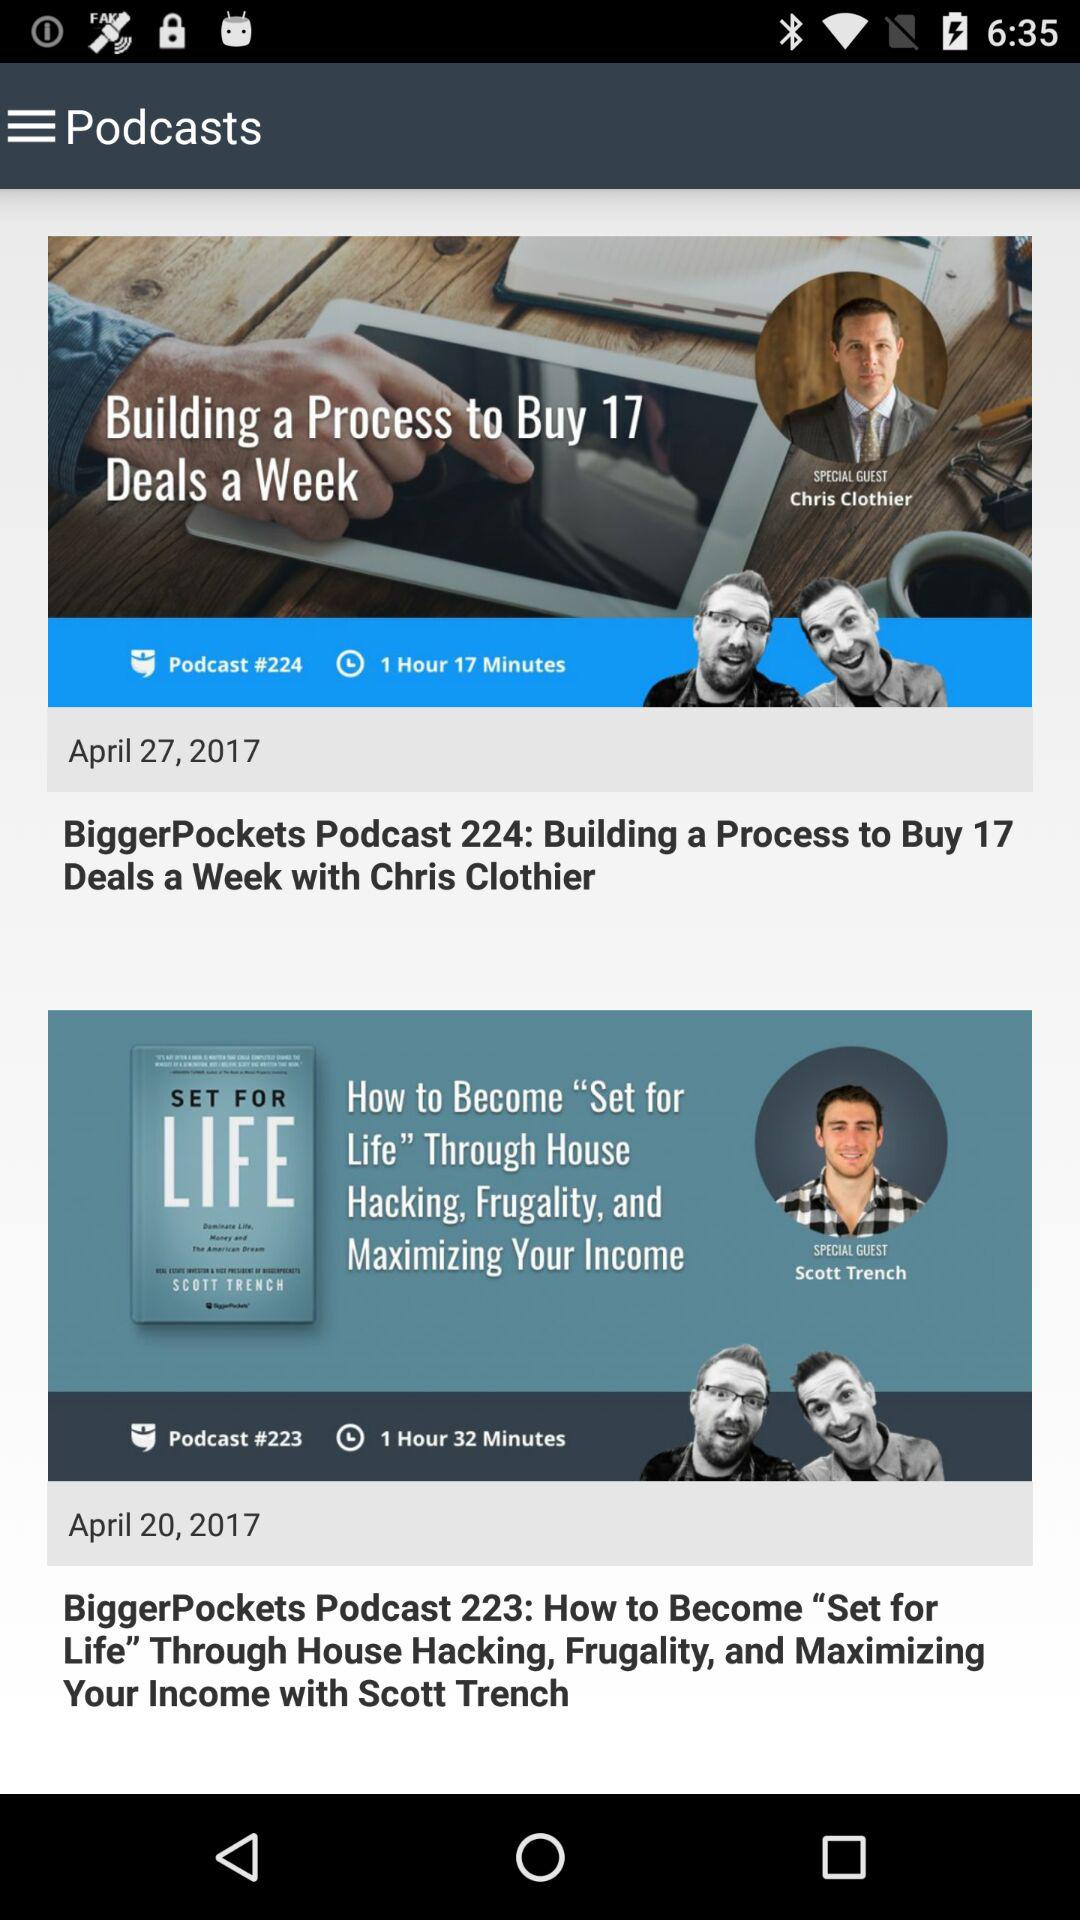How many minutes longer is the second podcast than the first?
Answer the question using a single word or phrase. 15 minutes 